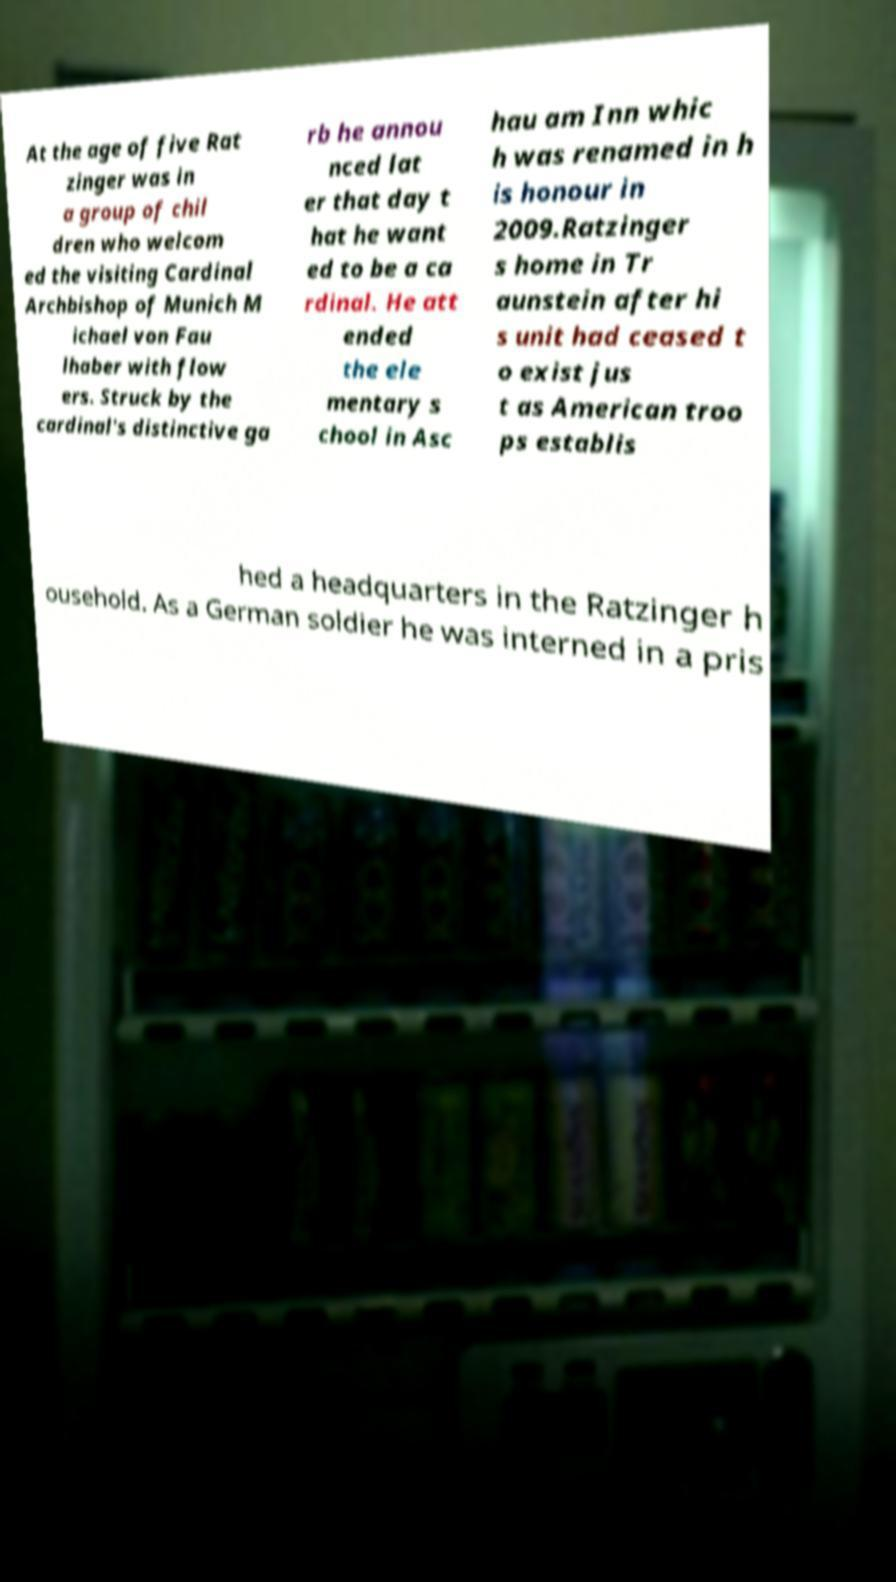Please identify and transcribe the text found in this image. At the age of five Rat zinger was in a group of chil dren who welcom ed the visiting Cardinal Archbishop of Munich M ichael von Fau lhaber with flow ers. Struck by the cardinal's distinctive ga rb he annou nced lat er that day t hat he want ed to be a ca rdinal. He att ended the ele mentary s chool in Asc hau am Inn whic h was renamed in h is honour in 2009.Ratzinger s home in Tr aunstein after hi s unit had ceased t o exist jus t as American troo ps establis hed a headquarters in the Ratzinger h ousehold. As a German soldier he was interned in a pris 